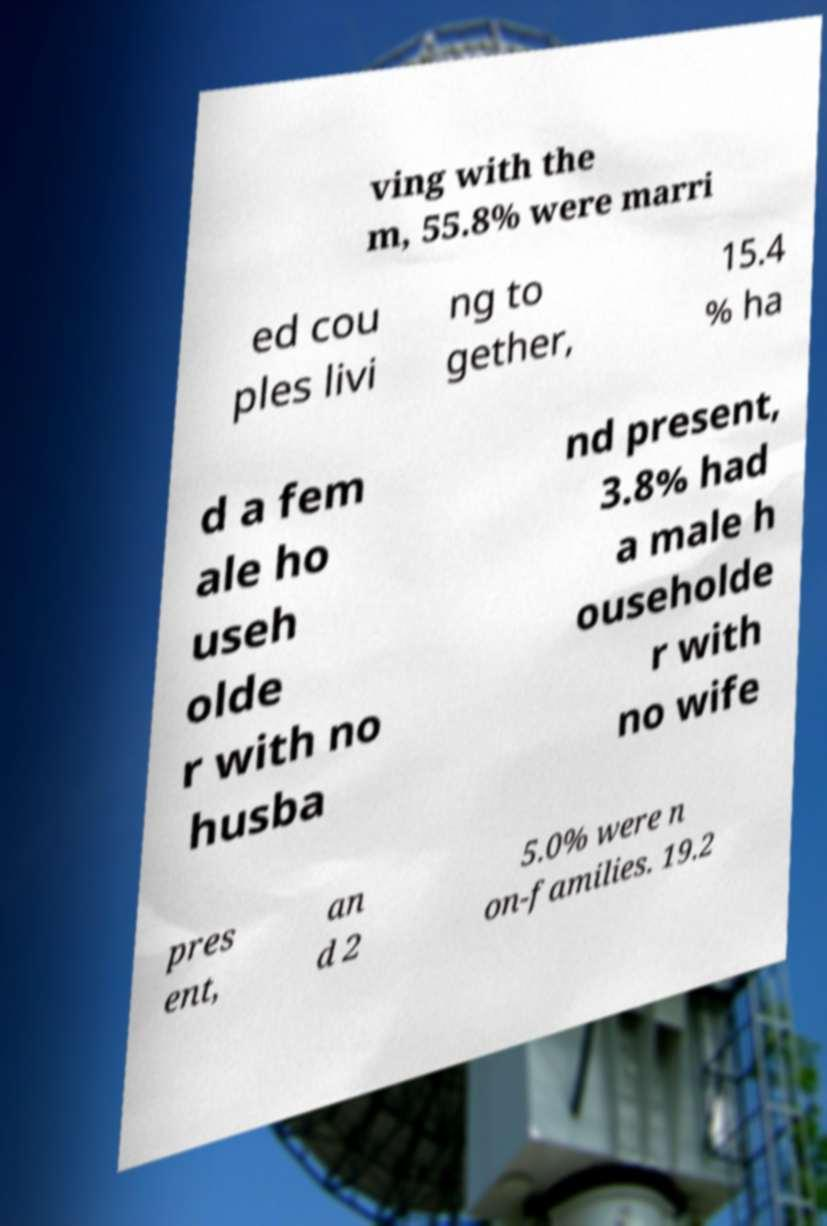Can you accurately transcribe the text from the provided image for me? ving with the m, 55.8% were marri ed cou ples livi ng to gether, 15.4 % ha d a fem ale ho useh olde r with no husba nd present, 3.8% had a male h ouseholde r with no wife pres ent, an d 2 5.0% were n on-families. 19.2 